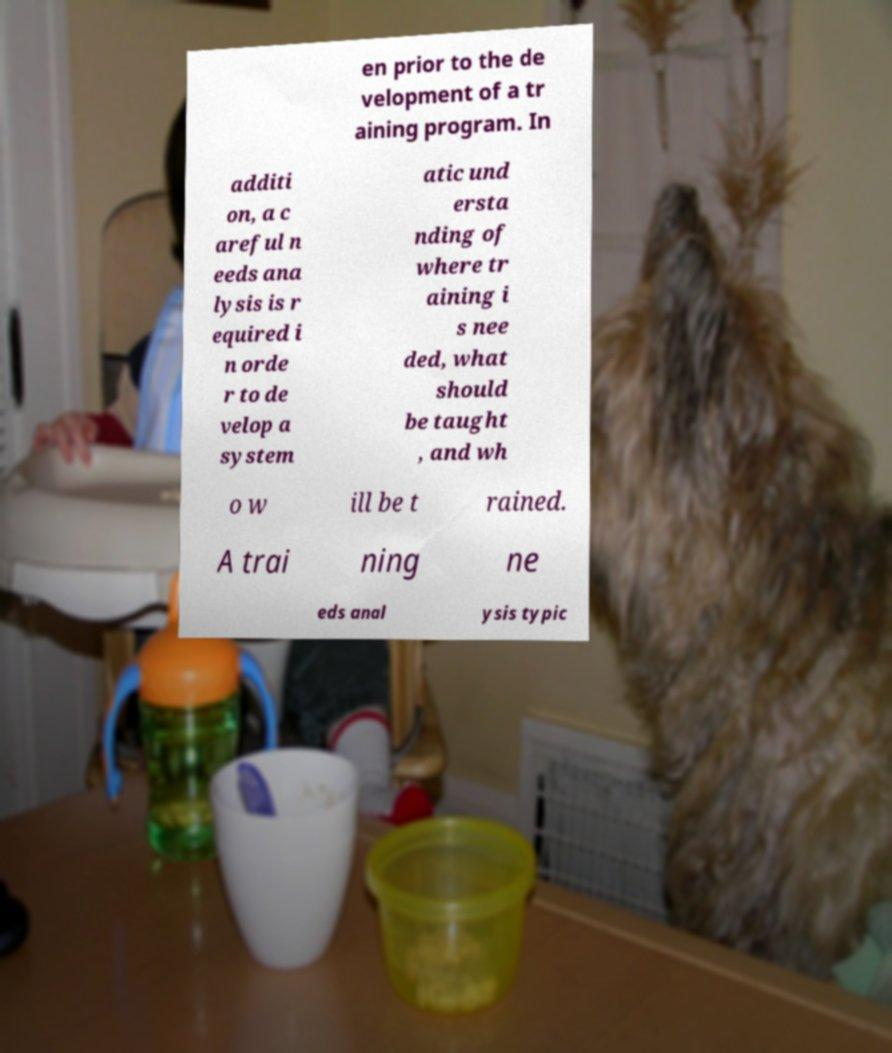Can you accurately transcribe the text from the provided image for me? en prior to the de velopment of a tr aining program. In additi on, a c areful n eeds ana lysis is r equired i n orde r to de velop a system atic und ersta nding of where tr aining i s nee ded, what should be taught , and wh o w ill be t rained. A trai ning ne eds anal ysis typic 